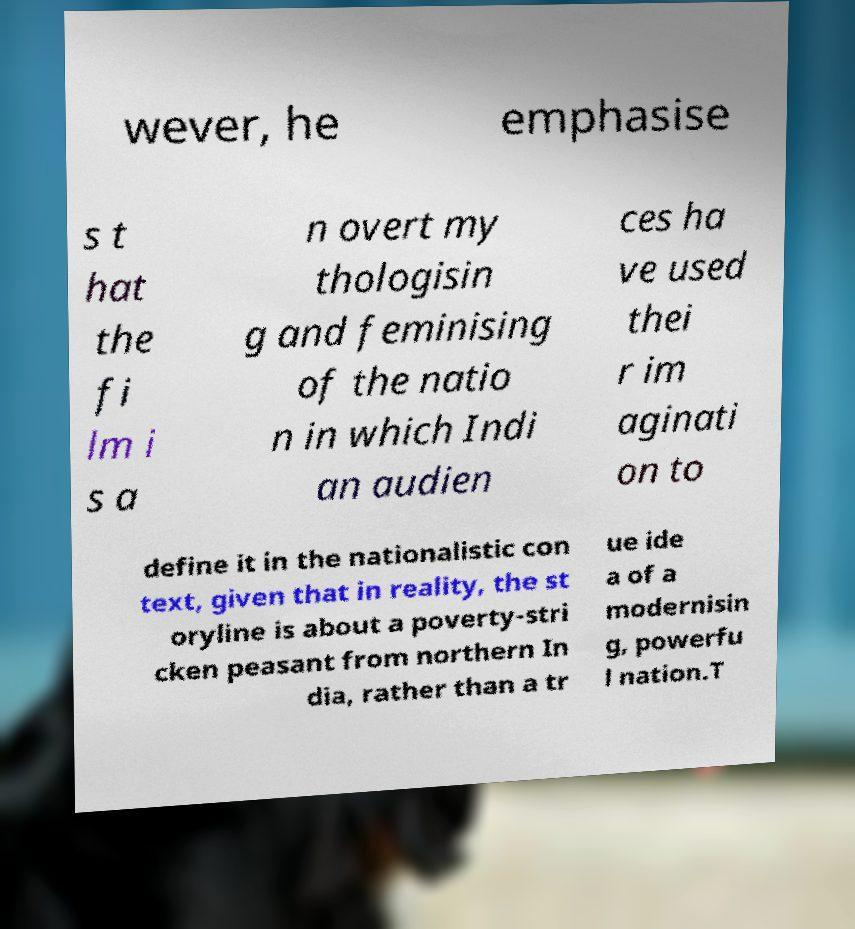For documentation purposes, I need the text within this image transcribed. Could you provide that? wever, he emphasise s t hat the fi lm i s a n overt my thologisin g and feminising of the natio n in which Indi an audien ces ha ve used thei r im aginati on to define it in the nationalistic con text, given that in reality, the st oryline is about a poverty-stri cken peasant from northern In dia, rather than a tr ue ide a of a modernisin g, powerfu l nation.T 